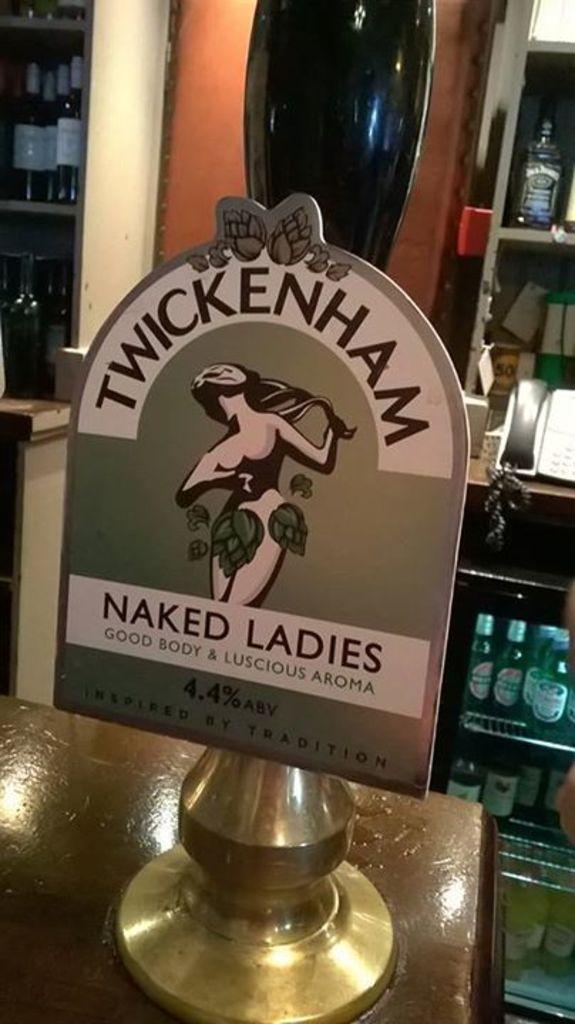Provide a one-sentence caption for the provided image. A Pub has Twickenham Naked Ladies Ale on tap. 